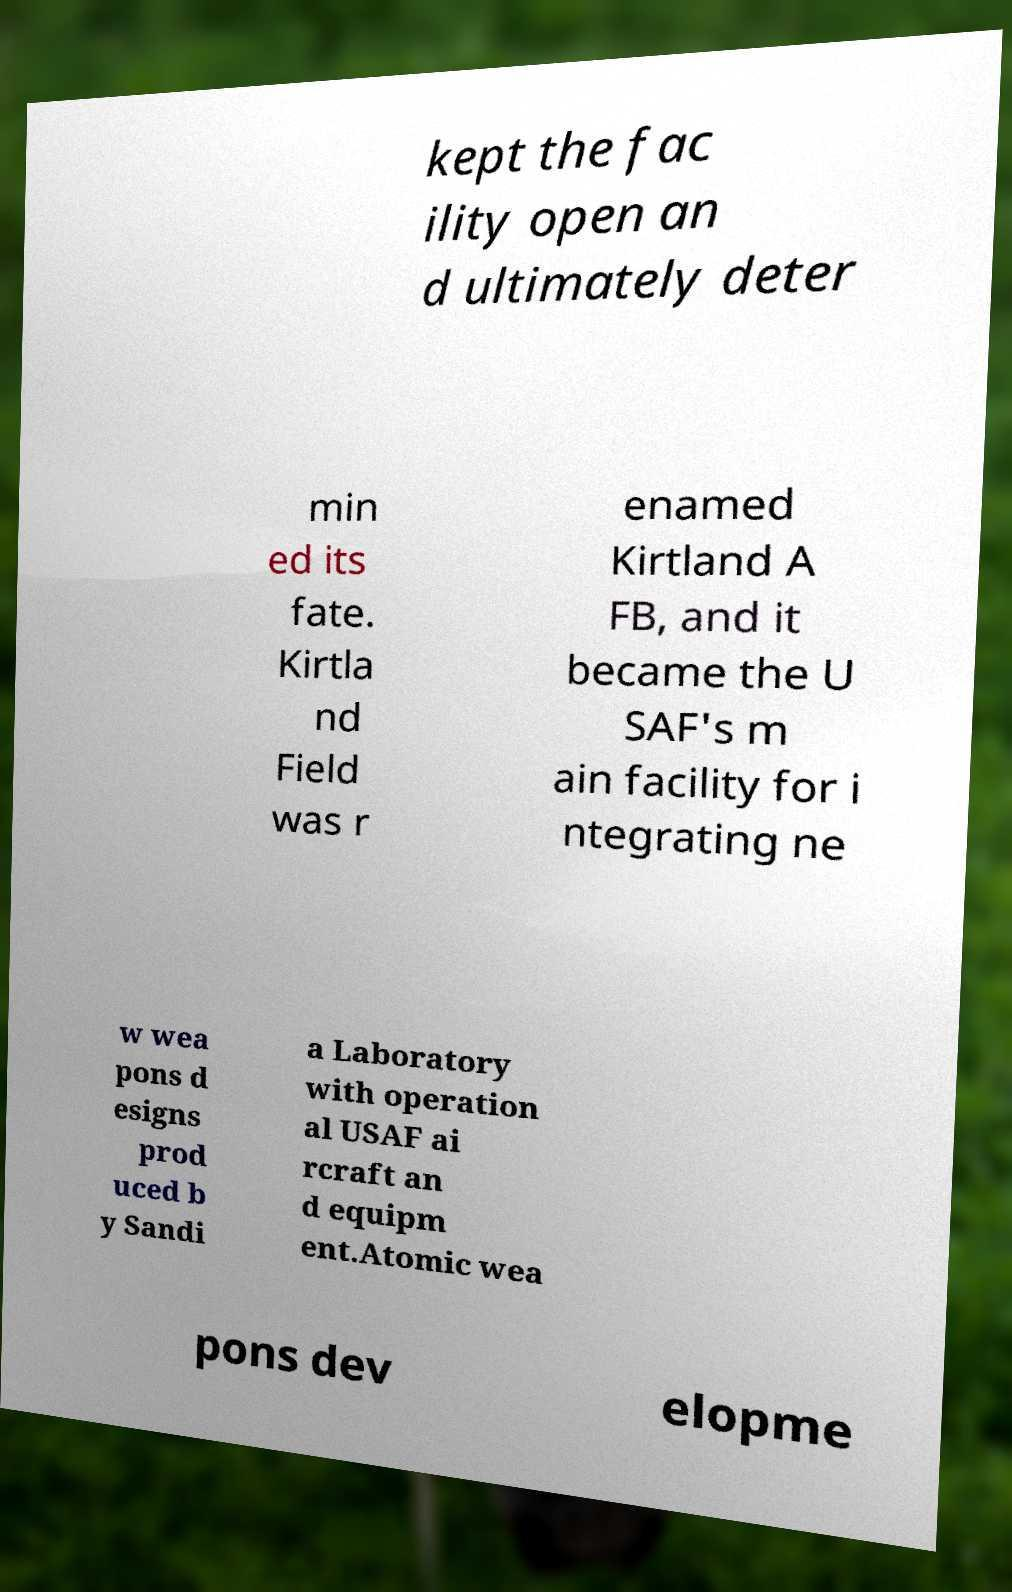There's text embedded in this image that I need extracted. Can you transcribe it verbatim? kept the fac ility open an d ultimately deter min ed its fate. Kirtla nd Field was r enamed Kirtland A FB, and it became the U SAF's m ain facility for i ntegrating ne w wea pons d esigns prod uced b y Sandi a Laboratory with operation al USAF ai rcraft an d equipm ent.Atomic wea pons dev elopme 